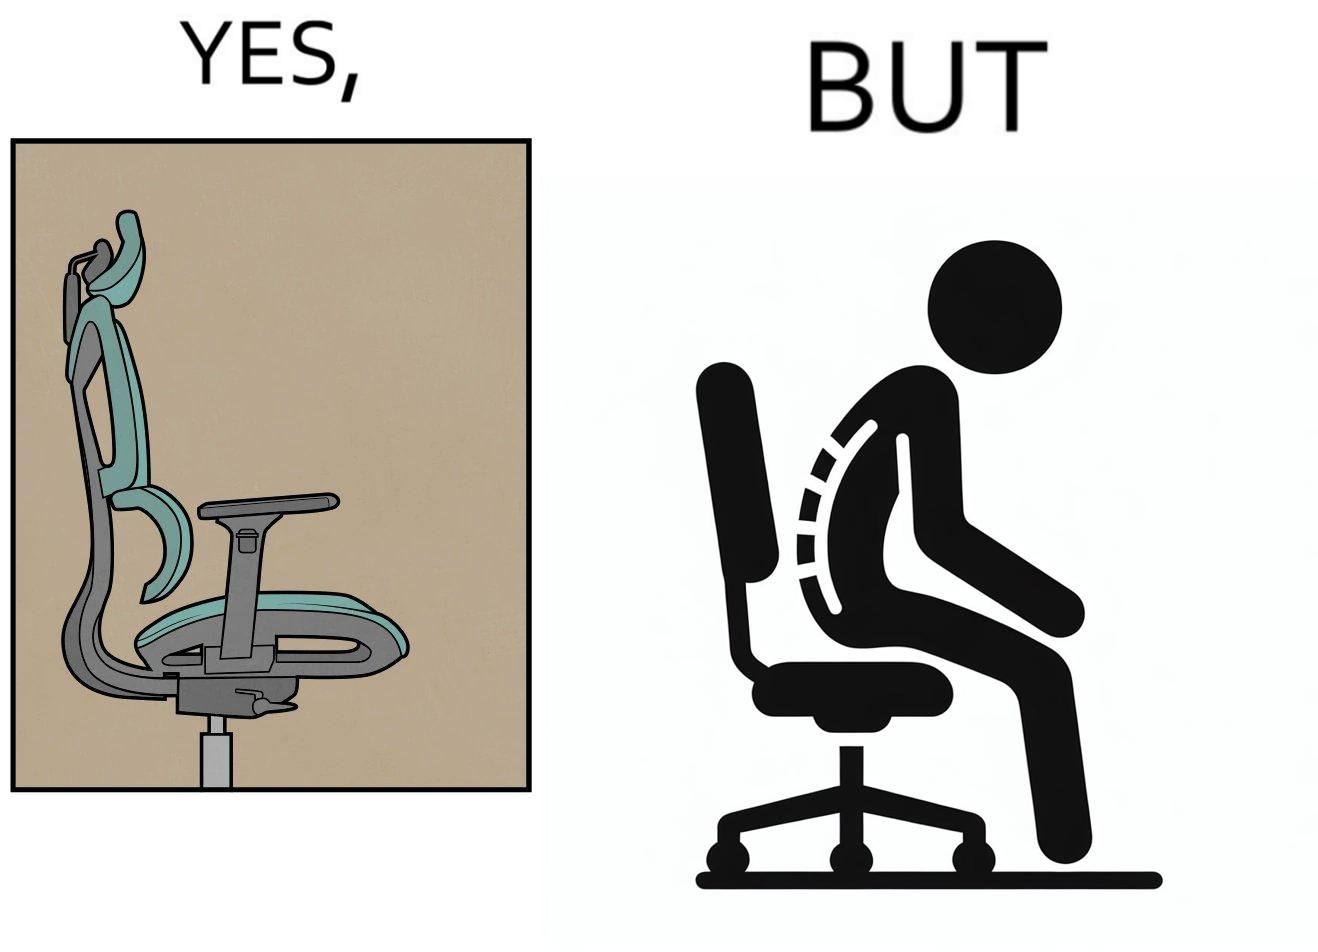Describe the contrast between the left and right parts of this image. In the left part of the image: an ergonomic chair. In the right part of the image: a person sitting on a ergonomic chair with a bent spine. 